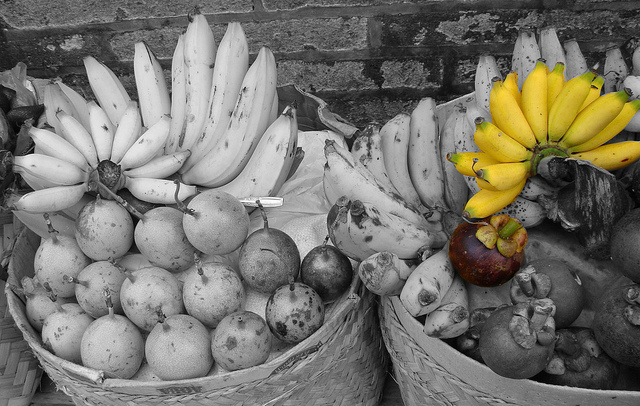Suppose you are writing a short story about a fruit vendor at a local market. Begin with a detailed description of the vendor's stall based on this image. The vendor's stall at the bustling market is a vibrant array of colors and textures, immediately drawing the eye. Nestled against a backdrop of rustic brickwork, two large woven baskets take center stage. The left basket, filled with clusters of pristine bananas and various monochrome round fruits, captures the charm of tradition and nostalgia. Beside it, the right basket bursts with life, showcasing stacks of yellow bananas that glisten under the sunlight, juxtaposed with a medley of other intriguing fruits. Each fruit tells a story of seasons past and the diligent hands that harvested them. The vendor, with an inviting smile, beckons the patrons, offering them a taste of both the past and the present. Continue the story by describing how the vendor interacts with a curious customer who has never seen the exotic purple fruit before. The vendor's eyes twinkled as a curious customer approached the stall, eyes wide with wonder at the exotic purple fruit nestled amongst the bananas. 'Ah, I see you've found our star attraction,' the vendor said warmly. The customer leaned in closer, captivated by the fruit's unusual hue and size. 'What is this?' they asked, touching the smooth, glossy skin. 'This,' the vendor began, 'is a Seraphina, a rare delicacy known for its heavenly taste and creamy texture.' The vendor gently picked one up, slicing it open to reveal a vibrant, juicy interior. 'It's a symphony of flavors,' the vendor continued, offering a sharegpt4v/sample. The customer took a hesitant bite, their face lighting up with delight as the sweet, tangy taste exploded in their mouth. 'Incredible,' they murmured, savoring the unique blend of flavors. The vendor smiled, pleased to have introduced yet another person to the wonders of the Seraphina. 